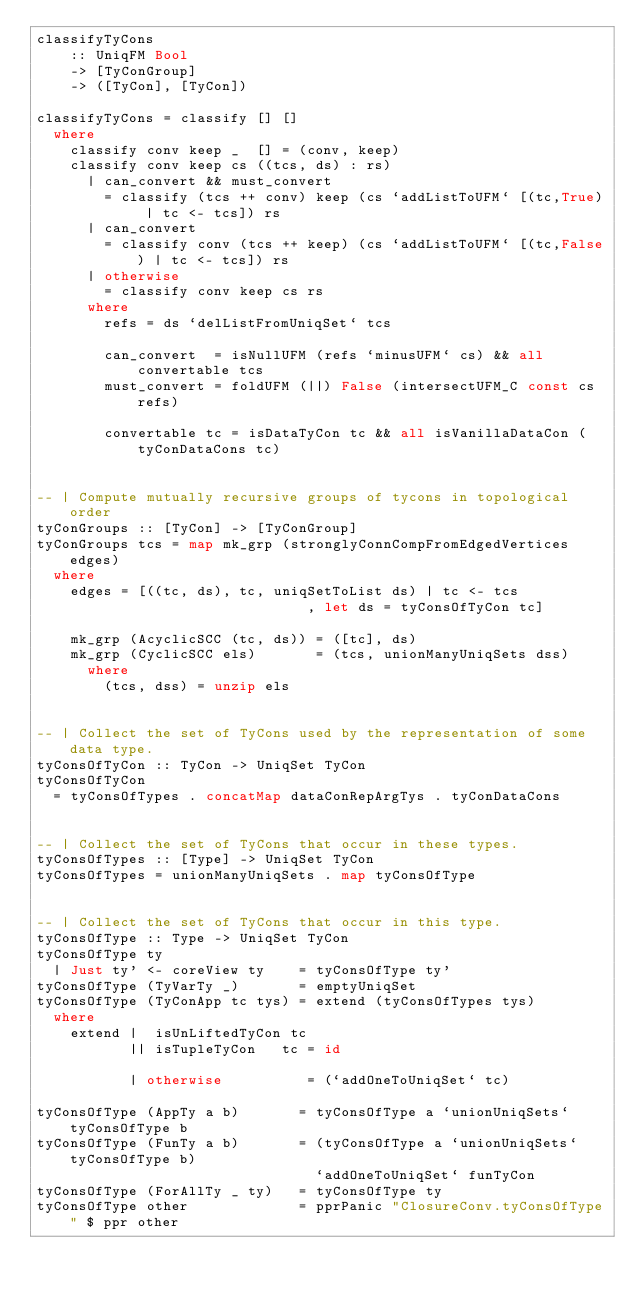Convert code to text. <code><loc_0><loc_0><loc_500><loc_500><_Haskell_>classifyTyCons 
	:: UniqFM Bool
	-> [TyConGroup]
	-> ([TyCon], [TyCon])

classifyTyCons = classify [] []
  where
    classify conv keep _  [] = (conv, keep)
    classify conv keep cs ((tcs, ds) : rs)
      | can_convert && must_convert
        = classify (tcs ++ conv) keep (cs `addListToUFM` [(tc,True) | tc <- tcs]) rs
      | can_convert
        = classify conv (tcs ++ keep) (cs `addListToUFM` [(tc,False) | tc <- tcs]) rs
      | otherwise
        = classify conv keep cs rs
      where
        refs = ds `delListFromUniqSet` tcs

        can_convert  = isNullUFM (refs `minusUFM` cs) && all convertable tcs
        must_convert = foldUFM (||) False (intersectUFM_C const cs refs)

        convertable tc = isDataTyCon tc && all isVanillaDataCon (tyConDataCons tc)


-- | Compute mutually recursive groups of tycons in topological order
tyConGroups :: [TyCon] -> [TyConGroup]
tyConGroups tcs = map mk_grp (stronglyConnCompFromEdgedVertices edges)
  where
    edges = [((tc, ds), tc, uniqSetToList ds) | tc <- tcs
                                , let ds = tyConsOfTyCon tc]

    mk_grp (AcyclicSCC (tc, ds)) = ([tc], ds)
    mk_grp (CyclicSCC els)       = (tcs, unionManyUniqSets dss)
      where
        (tcs, dss) = unzip els


-- | Collect the set of TyCons used by the representation of some data type.
tyConsOfTyCon :: TyCon -> UniqSet TyCon
tyConsOfTyCon
  = tyConsOfTypes . concatMap dataConRepArgTys . tyConDataCons


-- | Collect the set of TyCons that occur in these types.
tyConsOfTypes :: [Type] -> UniqSet TyCon
tyConsOfTypes = unionManyUniqSets . map tyConsOfType


-- | Collect the set of TyCons that occur in this type.
tyConsOfType :: Type -> UniqSet TyCon
tyConsOfType ty
  | Just ty' <- coreView ty    = tyConsOfType ty'
tyConsOfType (TyVarTy _)       = emptyUniqSet
tyConsOfType (TyConApp tc tys) = extend (tyConsOfTypes tys)
  where
    extend |  isUnLiftedTyCon tc
           || isTupleTyCon   tc = id

           | otherwise          = (`addOneToUniqSet` tc)

tyConsOfType (AppTy a b)       = tyConsOfType a `unionUniqSets` tyConsOfType b
tyConsOfType (FunTy a b)       = (tyConsOfType a `unionUniqSets` tyConsOfType b)
                                 `addOneToUniqSet` funTyCon
tyConsOfType (ForAllTy _ ty)   = tyConsOfType ty
tyConsOfType other             = pprPanic "ClosureConv.tyConsOfType" $ ppr other

</code> 